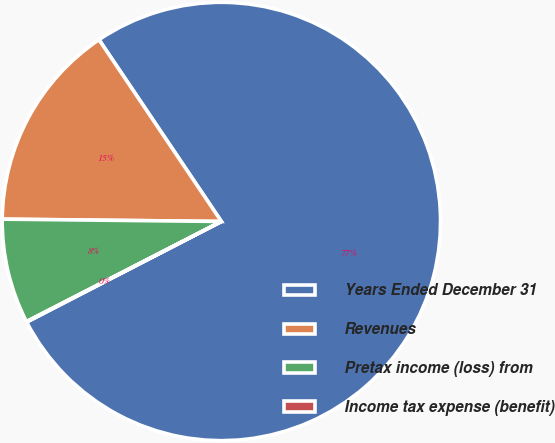Convert chart to OTSL. <chart><loc_0><loc_0><loc_500><loc_500><pie_chart><fcel>Years Ended December 31<fcel>Revenues<fcel>Pretax income (loss) from<fcel>Income tax expense (benefit)<nl><fcel>76.84%<fcel>15.4%<fcel>7.72%<fcel>0.04%<nl></chart> 